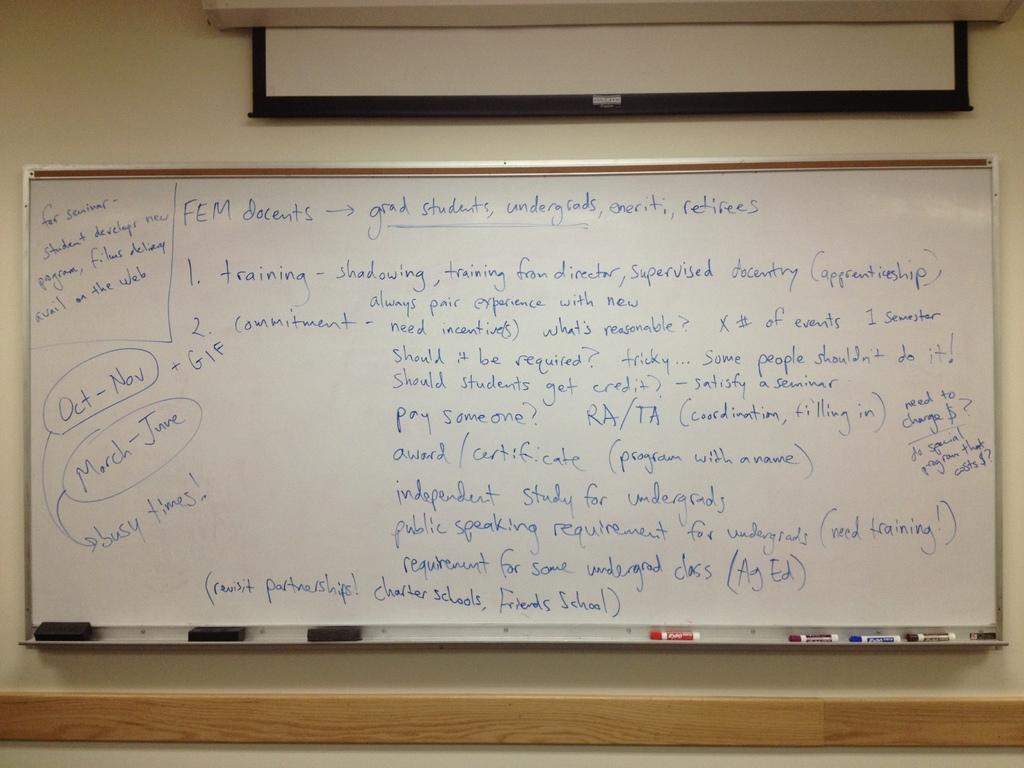<image>
Provide a brief description of the given image. a white board with months written on it 